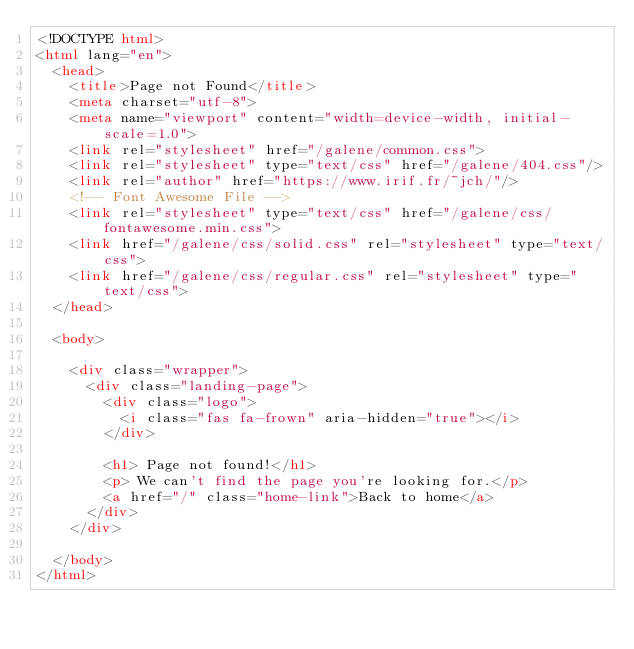Convert code to text. <code><loc_0><loc_0><loc_500><loc_500><_HTML_><!DOCTYPE html>
<html lang="en">
  <head>
    <title>Page not Found</title>
    <meta charset="utf-8">
    <meta name="viewport" content="width=device-width, initial-scale=1.0">
    <link rel="stylesheet" href="/galene/common.css">
    <link rel="stylesheet" type="text/css" href="/galene/404.css"/>
    <link rel="author" href="https://www.irif.fr/~jch/"/>
    <!-- Font Awesome File -->
    <link rel="stylesheet" type="text/css" href="/galene/css/fontawesome.min.css">
    <link href="/galene/css/solid.css" rel="stylesheet" type="text/css">
    <link href="/galene/css/regular.css" rel="stylesheet" type="text/css">
  </head>

  <body>

    <div class="wrapper">
      <div class="landing-page">
        <div class="logo">
          <i class="fas fa-frown" aria-hidden="true"></i>
        </div>

        <h1> Page not found!</h1>
        <p> We can't find the page you're looking for.</p>
        <a href="/" class="home-link">Back to home</a>
      </div>
    </div>

  </body>
</html>
</code> 